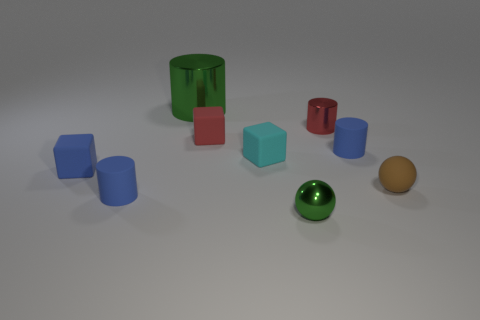There is a small cube that is the same color as the tiny shiny cylinder; what material is it?
Provide a succinct answer. Rubber. There is a green metallic thing in front of the green metal cylinder; does it have the same shape as the small brown thing to the right of the small cyan rubber thing?
Provide a short and direct response. Yes. What is the material of the red thing that is the same shape as the large green metallic object?
Your answer should be very brief. Metal. Are there any big brown rubber cylinders?
Give a very brief answer. No. There is a matte object that is both left of the small green metallic ball and behind the small cyan matte cube; what size is it?
Give a very brief answer. Small. What is the shape of the tiny cyan rubber object?
Ensure brevity in your answer.  Cube. There is a blue cylinder that is left of the red metallic cylinder; are there any tiny blue things behind it?
Provide a short and direct response. Yes. There is a green object that is the same size as the cyan object; what is it made of?
Your answer should be very brief. Metal. Are there any red shiny cylinders of the same size as the brown ball?
Offer a very short reply. Yes. There is a green thing behind the tiny green shiny object; what material is it?
Offer a very short reply. Metal. 